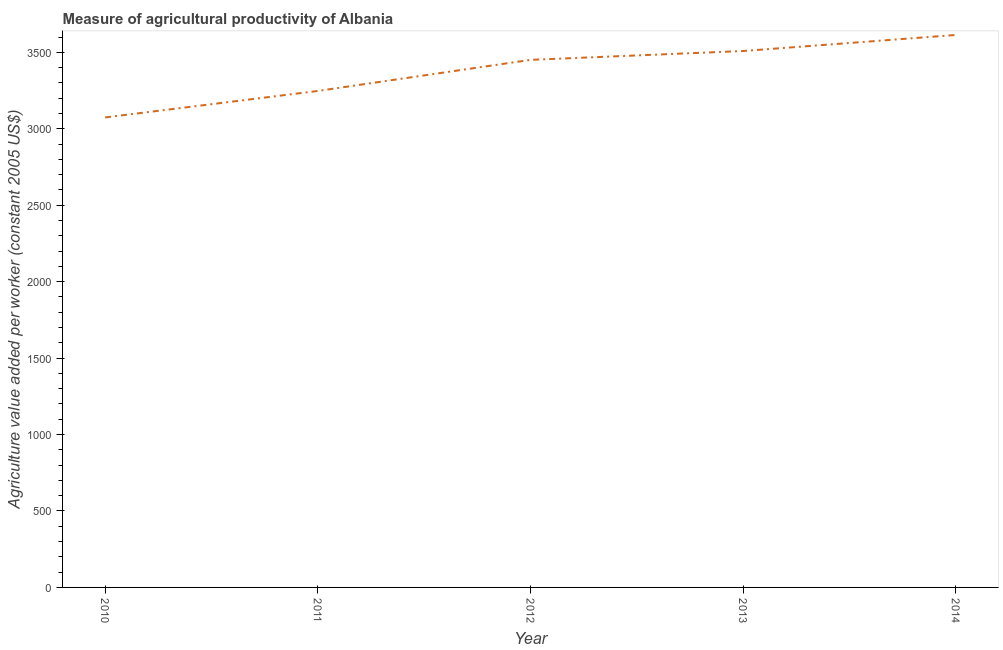What is the agriculture value added per worker in 2013?
Give a very brief answer. 3508.83. Across all years, what is the maximum agriculture value added per worker?
Offer a terse response. 3613.87. Across all years, what is the minimum agriculture value added per worker?
Give a very brief answer. 3074.35. In which year was the agriculture value added per worker maximum?
Make the answer very short. 2014. In which year was the agriculture value added per worker minimum?
Give a very brief answer. 2010. What is the sum of the agriculture value added per worker?
Provide a succinct answer. 1.69e+04. What is the difference between the agriculture value added per worker in 2011 and 2014?
Provide a succinct answer. -366.33. What is the average agriculture value added per worker per year?
Give a very brief answer. 3379.12. What is the median agriculture value added per worker?
Make the answer very short. 3451. Do a majority of the years between 2013 and 2014 (inclusive) have agriculture value added per worker greater than 1300 US$?
Your answer should be compact. Yes. What is the ratio of the agriculture value added per worker in 2010 to that in 2012?
Make the answer very short. 0.89. What is the difference between the highest and the second highest agriculture value added per worker?
Your response must be concise. 105.03. Is the sum of the agriculture value added per worker in 2013 and 2014 greater than the maximum agriculture value added per worker across all years?
Offer a very short reply. Yes. What is the difference between the highest and the lowest agriculture value added per worker?
Provide a succinct answer. 539.52. In how many years, is the agriculture value added per worker greater than the average agriculture value added per worker taken over all years?
Ensure brevity in your answer.  3. How many lines are there?
Keep it short and to the point. 1. What is the difference between two consecutive major ticks on the Y-axis?
Ensure brevity in your answer.  500. Does the graph contain any zero values?
Provide a succinct answer. No. What is the title of the graph?
Provide a succinct answer. Measure of agricultural productivity of Albania. What is the label or title of the X-axis?
Provide a short and direct response. Year. What is the label or title of the Y-axis?
Provide a succinct answer. Agriculture value added per worker (constant 2005 US$). What is the Agriculture value added per worker (constant 2005 US$) in 2010?
Provide a succinct answer. 3074.35. What is the Agriculture value added per worker (constant 2005 US$) in 2011?
Make the answer very short. 3247.53. What is the Agriculture value added per worker (constant 2005 US$) of 2012?
Offer a terse response. 3451. What is the Agriculture value added per worker (constant 2005 US$) of 2013?
Offer a terse response. 3508.83. What is the Agriculture value added per worker (constant 2005 US$) of 2014?
Your response must be concise. 3613.87. What is the difference between the Agriculture value added per worker (constant 2005 US$) in 2010 and 2011?
Offer a very short reply. -173.19. What is the difference between the Agriculture value added per worker (constant 2005 US$) in 2010 and 2012?
Provide a short and direct response. -376.65. What is the difference between the Agriculture value added per worker (constant 2005 US$) in 2010 and 2013?
Offer a very short reply. -434.48. What is the difference between the Agriculture value added per worker (constant 2005 US$) in 2010 and 2014?
Give a very brief answer. -539.52. What is the difference between the Agriculture value added per worker (constant 2005 US$) in 2011 and 2012?
Provide a short and direct response. -203.46. What is the difference between the Agriculture value added per worker (constant 2005 US$) in 2011 and 2013?
Make the answer very short. -261.3. What is the difference between the Agriculture value added per worker (constant 2005 US$) in 2011 and 2014?
Offer a terse response. -366.33. What is the difference between the Agriculture value added per worker (constant 2005 US$) in 2012 and 2013?
Your response must be concise. -57.84. What is the difference between the Agriculture value added per worker (constant 2005 US$) in 2012 and 2014?
Keep it short and to the point. -162.87. What is the difference between the Agriculture value added per worker (constant 2005 US$) in 2013 and 2014?
Your answer should be very brief. -105.03. What is the ratio of the Agriculture value added per worker (constant 2005 US$) in 2010 to that in 2011?
Make the answer very short. 0.95. What is the ratio of the Agriculture value added per worker (constant 2005 US$) in 2010 to that in 2012?
Keep it short and to the point. 0.89. What is the ratio of the Agriculture value added per worker (constant 2005 US$) in 2010 to that in 2013?
Your answer should be very brief. 0.88. What is the ratio of the Agriculture value added per worker (constant 2005 US$) in 2010 to that in 2014?
Your answer should be very brief. 0.85. What is the ratio of the Agriculture value added per worker (constant 2005 US$) in 2011 to that in 2012?
Keep it short and to the point. 0.94. What is the ratio of the Agriculture value added per worker (constant 2005 US$) in 2011 to that in 2013?
Ensure brevity in your answer.  0.93. What is the ratio of the Agriculture value added per worker (constant 2005 US$) in 2011 to that in 2014?
Give a very brief answer. 0.9. What is the ratio of the Agriculture value added per worker (constant 2005 US$) in 2012 to that in 2013?
Give a very brief answer. 0.98. What is the ratio of the Agriculture value added per worker (constant 2005 US$) in 2012 to that in 2014?
Make the answer very short. 0.95. What is the ratio of the Agriculture value added per worker (constant 2005 US$) in 2013 to that in 2014?
Offer a very short reply. 0.97. 